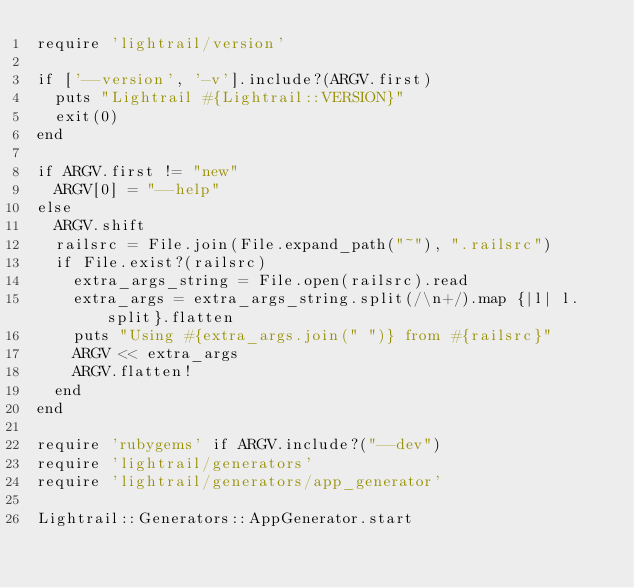<code> <loc_0><loc_0><loc_500><loc_500><_Ruby_>require 'lightrail/version'

if ['--version', '-v'].include?(ARGV.first)
  puts "Lightrail #{Lightrail::VERSION}"
  exit(0)
end

if ARGV.first != "new"
  ARGV[0] = "--help"
else
  ARGV.shift
  railsrc = File.join(File.expand_path("~"), ".railsrc")
  if File.exist?(railsrc)
    extra_args_string = File.open(railsrc).read
    extra_args = extra_args_string.split(/\n+/).map {|l| l.split}.flatten
    puts "Using #{extra_args.join(" ")} from #{railsrc}"
    ARGV << extra_args
    ARGV.flatten!
  end
end

require 'rubygems' if ARGV.include?("--dev")
require 'lightrail/generators'
require 'lightrail/generators/app_generator'

Lightrail::Generators::AppGenerator.start</code> 